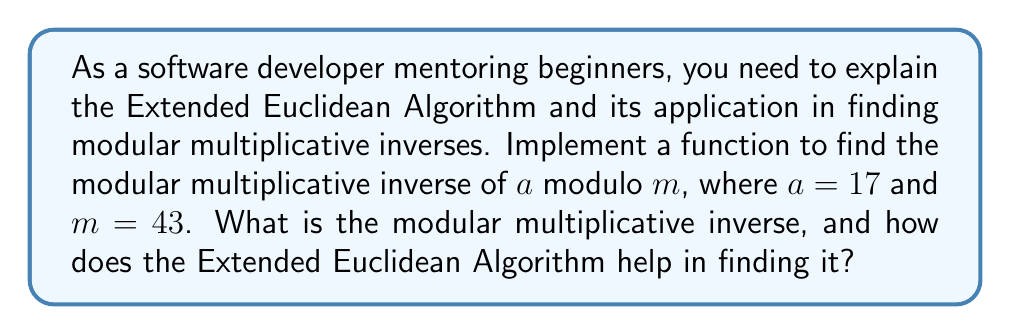Help me with this question. To find the modular multiplicative inverse of $a$ modulo $m$, we need to find a number $x$ such that:

$$(ax) \equiv 1 \pmod{m}$$

The Extended Euclidean Algorithm is an efficient method to find this inverse. It not only computes the greatest common divisor (GCD) of two numbers but also finds the coefficients of Bézout's identity. Here's how we can implement it:

1. Initialize variables:
   $r_1 = a$, $r_2 = m$
   $s_1 = 1$, $s_2 = 0$
   $t_1 = 0$, $t_2 = 1$

2. While $r_2 \neq 0$:
   a. Calculate quotient: $q = \lfloor r_1 / r_2 \rfloor$
   b. Update remainders: $r = r_1 - q \cdot r_2$, $r_1 = r_2$, $r_2 = r$
   c. Update coefficients:
      $s = s_1 - q \cdot s_2$, $s_1 = s_2$, $s_2 = s$
      $t = t_1 - q \cdot t_2$, $t_1 = t_2$, $t_2 = t$

3. If $r_1 = 1$, then $s_1$ is the modular multiplicative inverse of $a$ modulo $m$.

Let's apply this to our case where $a = 17$ and $m = 43$:

$$\begin{array}{r|r|r|r|r|r|r}
i & r_1 & r_2 & q & s_1 & s_2 & t_1 & t_2 \\
\hline
0 & 43 & 17 & 2 & 0 & 1 & 1 & 0 \\
1 & 17 & 9 & 1 & 1 & -2 & -2 & 1 \\
2 & 9 & 8 & 1 & -2 & 3 & 3 & -1 \\
3 & 8 & 1 & 8 & 3 & -5 & -5 & 2 \\
4 & 1 & 0 & - & -5 & 43 & 43 & -17 \\
\end{array}$$

The algorithm terminates when $r_2 = 0$, and we find that $r_1 = 1$, which means $\gcd(17, 43) = 1$, so the modular multiplicative inverse exists.

The modular multiplicative inverse is $s_1 = -5$. However, we need to ensure it's positive and less than $m$, so we add $m$ to get:

$$-5 + 43 = 38$$

We can verify: $17 \cdot 38 \equiv 1 \pmod{43}$

Indeed, $17 \cdot 38 = 646$, and $646 \equiv 1 \pmod{43}$.
Answer: The modular multiplicative inverse of 17 modulo 43 is 38. 